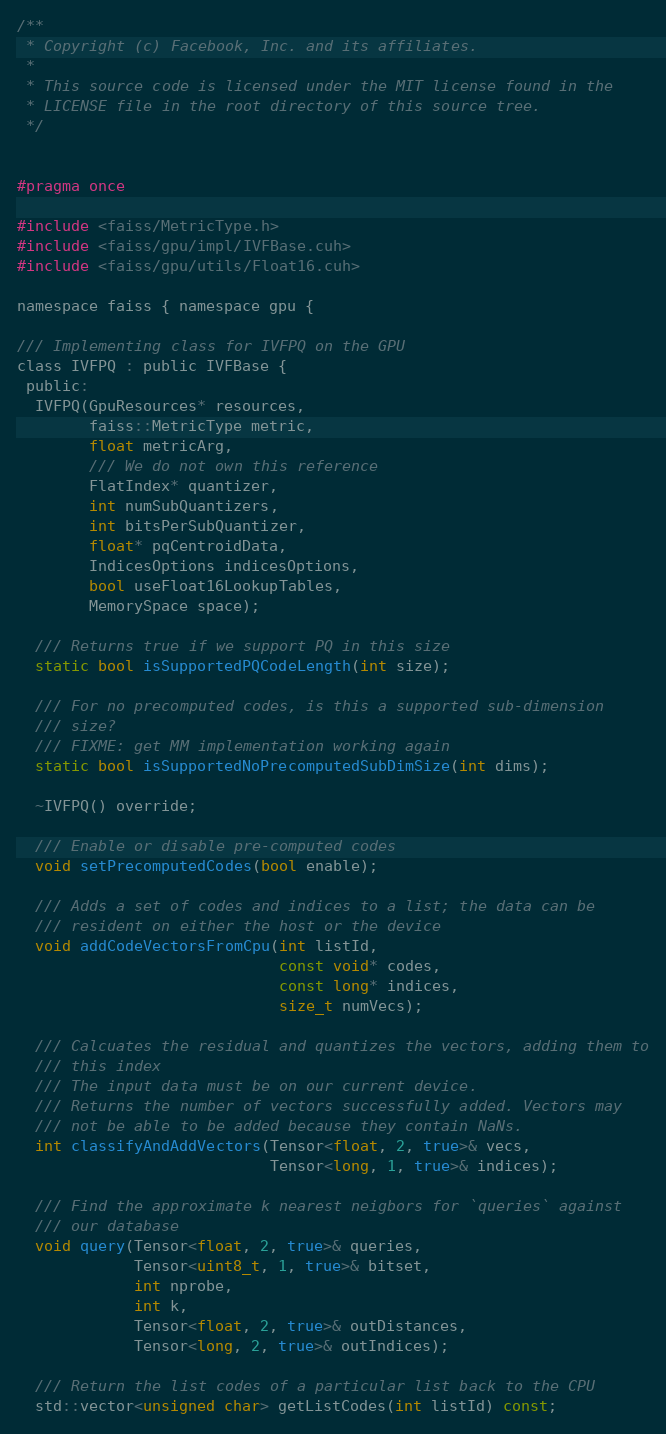Convert code to text. <code><loc_0><loc_0><loc_500><loc_500><_Cuda_>/**
 * Copyright (c) Facebook, Inc. and its affiliates.
 *
 * This source code is licensed under the MIT license found in the
 * LICENSE file in the root directory of this source tree.
 */


#pragma once

#include <faiss/MetricType.h>
#include <faiss/gpu/impl/IVFBase.cuh>
#include <faiss/gpu/utils/Float16.cuh>

namespace faiss { namespace gpu {

/// Implementing class for IVFPQ on the GPU
class IVFPQ : public IVFBase {
 public:
  IVFPQ(GpuResources* resources,
        faiss::MetricType metric,
        float metricArg,
        /// We do not own this reference
        FlatIndex* quantizer,
        int numSubQuantizers,
        int bitsPerSubQuantizer,
        float* pqCentroidData,
        IndicesOptions indicesOptions,
        bool useFloat16LookupTables,
        MemorySpace space);

  /// Returns true if we support PQ in this size
  static bool isSupportedPQCodeLength(int size);

  /// For no precomputed codes, is this a supported sub-dimension
  /// size?
  /// FIXME: get MM implementation working again
  static bool isSupportedNoPrecomputedSubDimSize(int dims);

  ~IVFPQ() override;

  /// Enable or disable pre-computed codes
  void setPrecomputedCodes(bool enable);

  /// Adds a set of codes and indices to a list; the data can be
  /// resident on either the host or the device
  void addCodeVectorsFromCpu(int listId,
                             const void* codes,
                             const long* indices,
                             size_t numVecs);

  /// Calcuates the residual and quantizes the vectors, adding them to
  /// this index
  /// The input data must be on our current device.
  /// Returns the number of vectors successfully added. Vectors may
  /// not be able to be added because they contain NaNs.
  int classifyAndAddVectors(Tensor<float, 2, true>& vecs,
                            Tensor<long, 1, true>& indices);

  /// Find the approximate k nearest neigbors for `queries` against
  /// our database
  void query(Tensor<float, 2, true>& queries,
             Tensor<uint8_t, 1, true>& bitset,
             int nprobe,
             int k,
             Tensor<float, 2, true>& outDistances,
             Tensor<long, 2, true>& outIndices);

  /// Return the list codes of a particular list back to the CPU
  std::vector<unsigned char> getListCodes(int listId) const;
</code> 